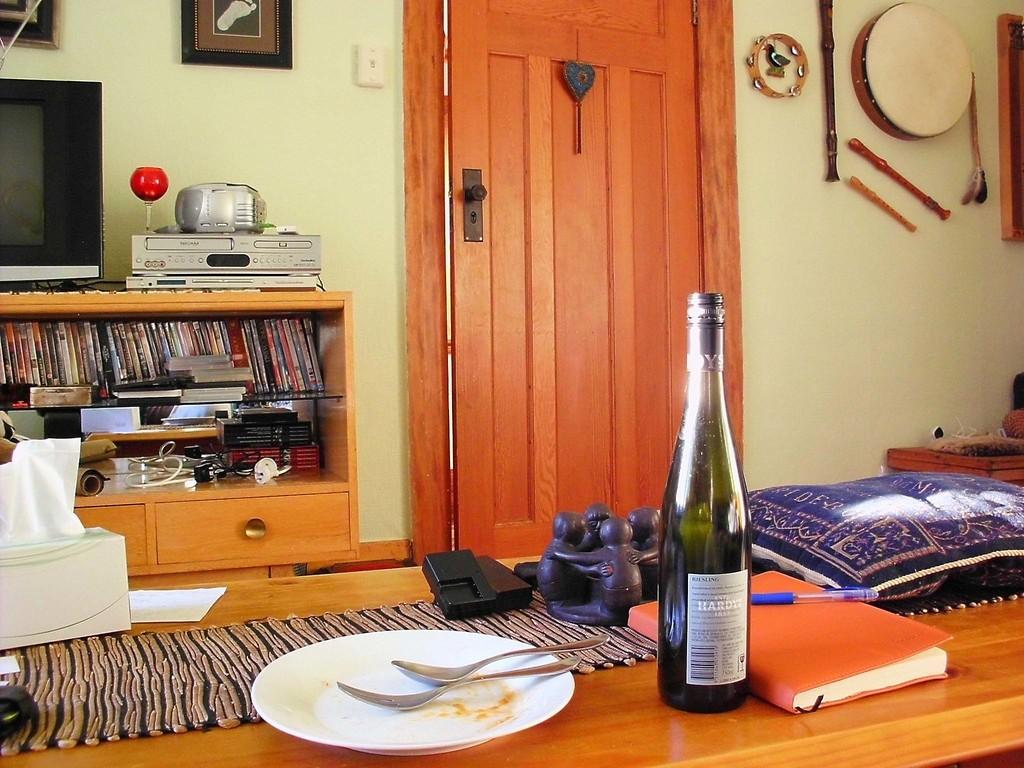What type of electronic device is present in the room? There is a TV in the room. What other electronic device can be found in the room? There is a music system in the room. What type of media is available in the room? There is a set of cassettes in the room. What is on the table in the room? There is a table with articles on it in the room. What type of decoration is on the wall in the room? There are musical instruments on the wall in the room. How many spots of soap can be seen on the musical instruments in the image? There is no soap present in the image, and therefore no spots of soap can be seen on the musical instruments. 